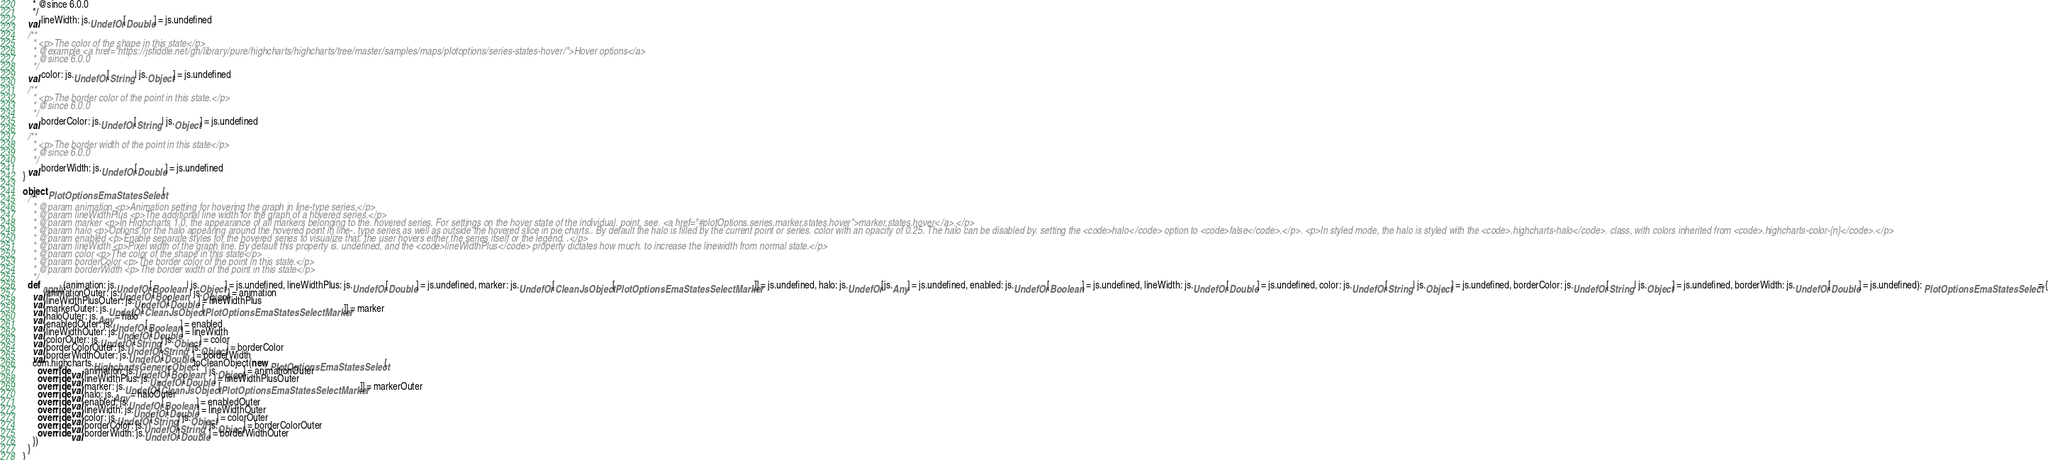Convert code to text. <code><loc_0><loc_0><loc_500><loc_500><_Scala_>    * @since 6.0.0
    */
  val lineWidth: js.UndefOr[Double] = js.undefined

  /**
    * <p>The color of the shape in this state</p>
    * @example <a href="https://jsfiddle.net/gh/library/pure/highcharts/highcharts/tree/master/samples/maps/plotoptions/series-states-hover/">Hover options</a>
    * @since 6.0.0
    */
  val color: js.UndefOr[String | js.Object] = js.undefined

  /**
    * <p>The border color of the point in this state.</p>
    * @since 6.0.0
    */
  val borderColor: js.UndefOr[String | js.Object] = js.undefined

  /**
    * <p>The border width of the point in this state</p>
    * @since 6.0.0
    */
  val borderWidth: js.UndefOr[Double] = js.undefined
}

object PlotOptionsEmaStatesSelect {
  /**
    * @param animation <p>Animation setting for hovering the graph in line-type series.</p>
    * @param lineWidthPlus <p>The additional line width for the graph of a hovered series.</p>
    * @param marker <p>In Highcharts 1.0, the appearance of all markers belonging to the. hovered series. For settings on the hover state of the individual. point, see. <a href="#plotOptions.series.marker.states.hover">marker.states.hover</a>.</p>
    * @param halo <p>Options for the halo appearing around the hovered point in line-. type series as well as outside the hovered slice in pie charts.. By default the halo is filled by the current point or series. color with an opacity of 0.25. The halo can be disabled by. setting the <code>halo</code> option to <code>false</code>.</p>. <p>In styled mode, the halo is styled with the <code>.highcharts-halo</code>. class, with colors inherited from <code>.highcharts-color-{n}</code>.</p>
    * @param enabled <p>Enable separate styles for the hovered series to visualize that. the user hovers either the series itself or the legend. .</p>
    * @param lineWidth <p>Pixel width of the graph line. By default this property is. undefined, and the <code>lineWidthPlus</code> property dictates how much. to increase the linewidth from normal state.</p>
    * @param color <p>The color of the shape in this state</p>
    * @param borderColor <p>The border color of the point in this state.</p>
    * @param borderWidth <p>The border width of the point in this state</p>
    */
  def apply(animation: js.UndefOr[Boolean | js.Object] = js.undefined, lineWidthPlus: js.UndefOr[Double] = js.undefined, marker: js.UndefOr[CleanJsObject[PlotOptionsEmaStatesSelectMarker]] = js.undefined, halo: js.UndefOr[js.Any] = js.undefined, enabled: js.UndefOr[Boolean] = js.undefined, lineWidth: js.UndefOr[Double] = js.undefined, color: js.UndefOr[String | js.Object] = js.undefined, borderColor: js.UndefOr[String | js.Object] = js.undefined, borderWidth: js.UndefOr[Double] = js.undefined): PlotOptionsEmaStatesSelect = {
    val animationOuter: js.UndefOr[Boolean | js.Object] = animation
    val lineWidthPlusOuter: js.UndefOr[Double] = lineWidthPlus
    val markerOuter: js.UndefOr[CleanJsObject[PlotOptionsEmaStatesSelectMarker]] = marker
    val haloOuter: js.Any = halo
    val enabledOuter: js.UndefOr[Boolean] = enabled
    val lineWidthOuter: js.UndefOr[Double] = lineWidth
    val colorOuter: js.UndefOr[String | js.Object] = color
    val borderColorOuter: js.UndefOr[String | js.Object] = borderColor
    val borderWidthOuter: js.UndefOr[Double] = borderWidth
    com.highcharts.HighchartsGenericObject.toCleanObject(new PlotOptionsEmaStatesSelect {
      override val animation: js.UndefOr[Boolean | js.Object] = animationOuter
      override val lineWidthPlus: js.UndefOr[Double] = lineWidthPlusOuter
      override val marker: js.UndefOr[CleanJsObject[PlotOptionsEmaStatesSelectMarker]] = markerOuter
      override val halo: js.Any = haloOuter
      override val enabled: js.UndefOr[Boolean] = enabledOuter
      override val lineWidth: js.UndefOr[Double] = lineWidthOuter
      override val color: js.UndefOr[String | js.Object] = colorOuter
      override val borderColor: js.UndefOr[String | js.Object] = borderColorOuter
      override val borderWidth: js.UndefOr[Double] = borderWidthOuter
    })
  }
}
</code> 